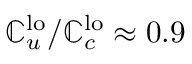<formula> <loc_0><loc_0><loc_500><loc_500>\mathbb { C } _ { u } ^ { l o } / \mathbb { C } _ { c } ^ { l o } \approx 0 . 9</formula> 